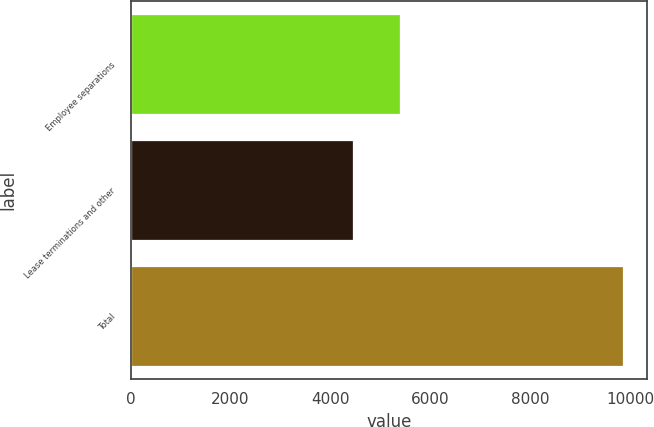<chart> <loc_0><loc_0><loc_500><loc_500><bar_chart><fcel>Employee separations<fcel>Lease terminations and other<fcel>Total<nl><fcel>5399<fcel>4453<fcel>9852<nl></chart> 